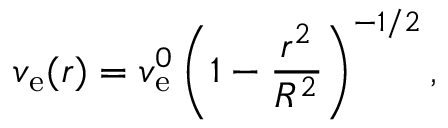<formula> <loc_0><loc_0><loc_500><loc_500>v _ { e } ( r ) = v _ { e } ^ { 0 } \left ( 1 - \frac { r ^ { 2 } } { R ^ { 2 } } \right ) ^ { - 1 / 2 } ,</formula> 